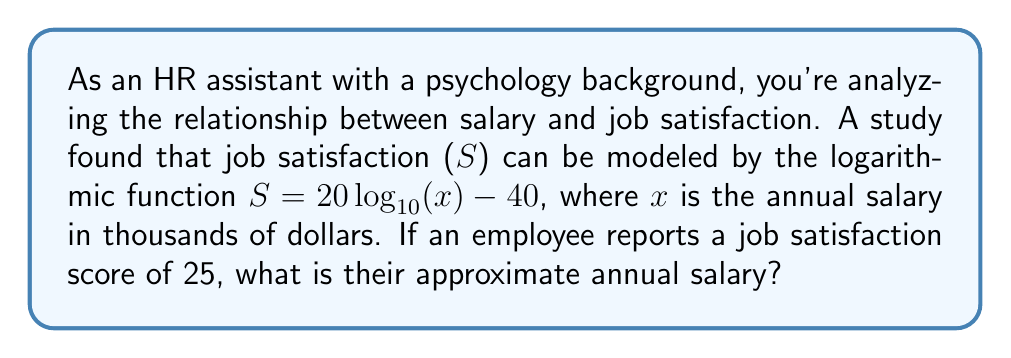Help me with this question. Let's approach this step-by-step:

1) We're given the function: $S = 20 \log_{10}(x) - 40$
   Where S is job satisfaction and x is salary in thousands of dollars.

2) We're told that S = 25. Let's substitute this into our equation:

   $25 = 20 \log_{10}(x) - 40$

3) First, let's add 40 to both sides:

   $65 = 20 \log_{10}(x)$

4) Now, divide both sides by 20:

   $\frac{65}{20} = \log_{10}(x)$

5) This simplifies to:

   $3.25 = \log_{10}(x)$

6) To solve for x, we need to apply the inverse function of $\log_{10}$, which is $10^x$:

   $10^{3.25} = x$

7) Using a calculator or computer, we can evaluate this:

   $x \approx 1778.28$

8) Remember, x was in thousands of dollars, so we need to multiply by 1000:

   Annual salary $\approx 1778280$ dollars
Answer: The employee's approximate annual salary is $1,778,280. 